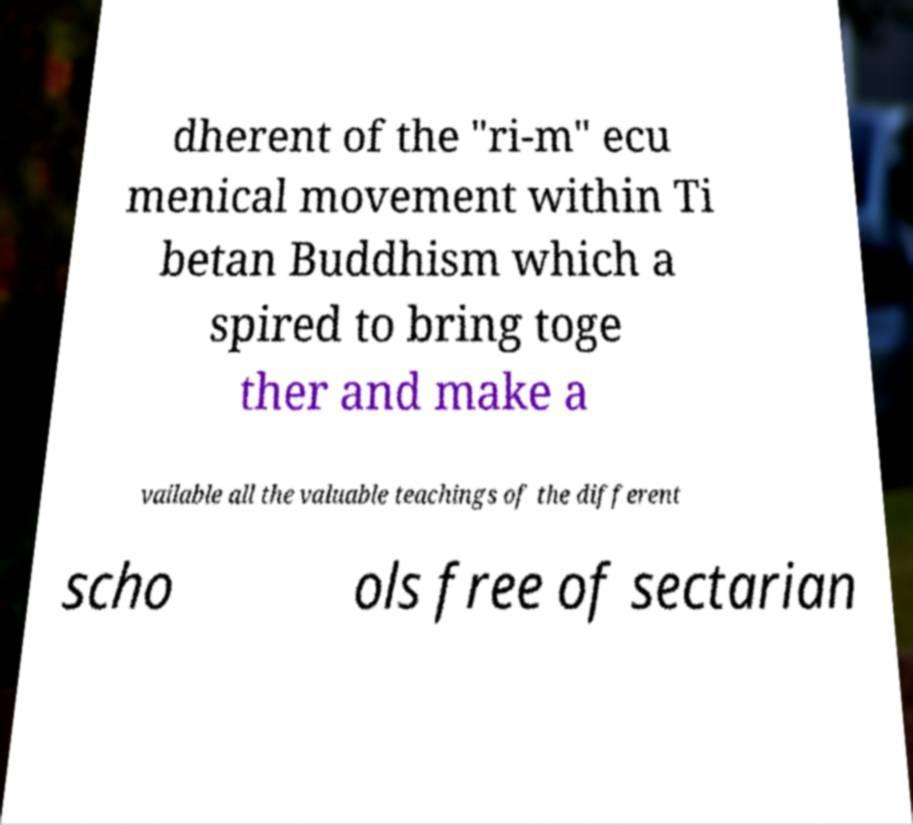Can you accurately transcribe the text from the provided image for me? dherent of the "ri-m" ecu menical movement within Ti betan Buddhism which a spired to bring toge ther and make a vailable all the valuable teachings of the different scho ols free of sectarian 